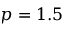<formula> <loc_0><loc_0><loc_500><loc_500>p = 1 . 5</formula> 